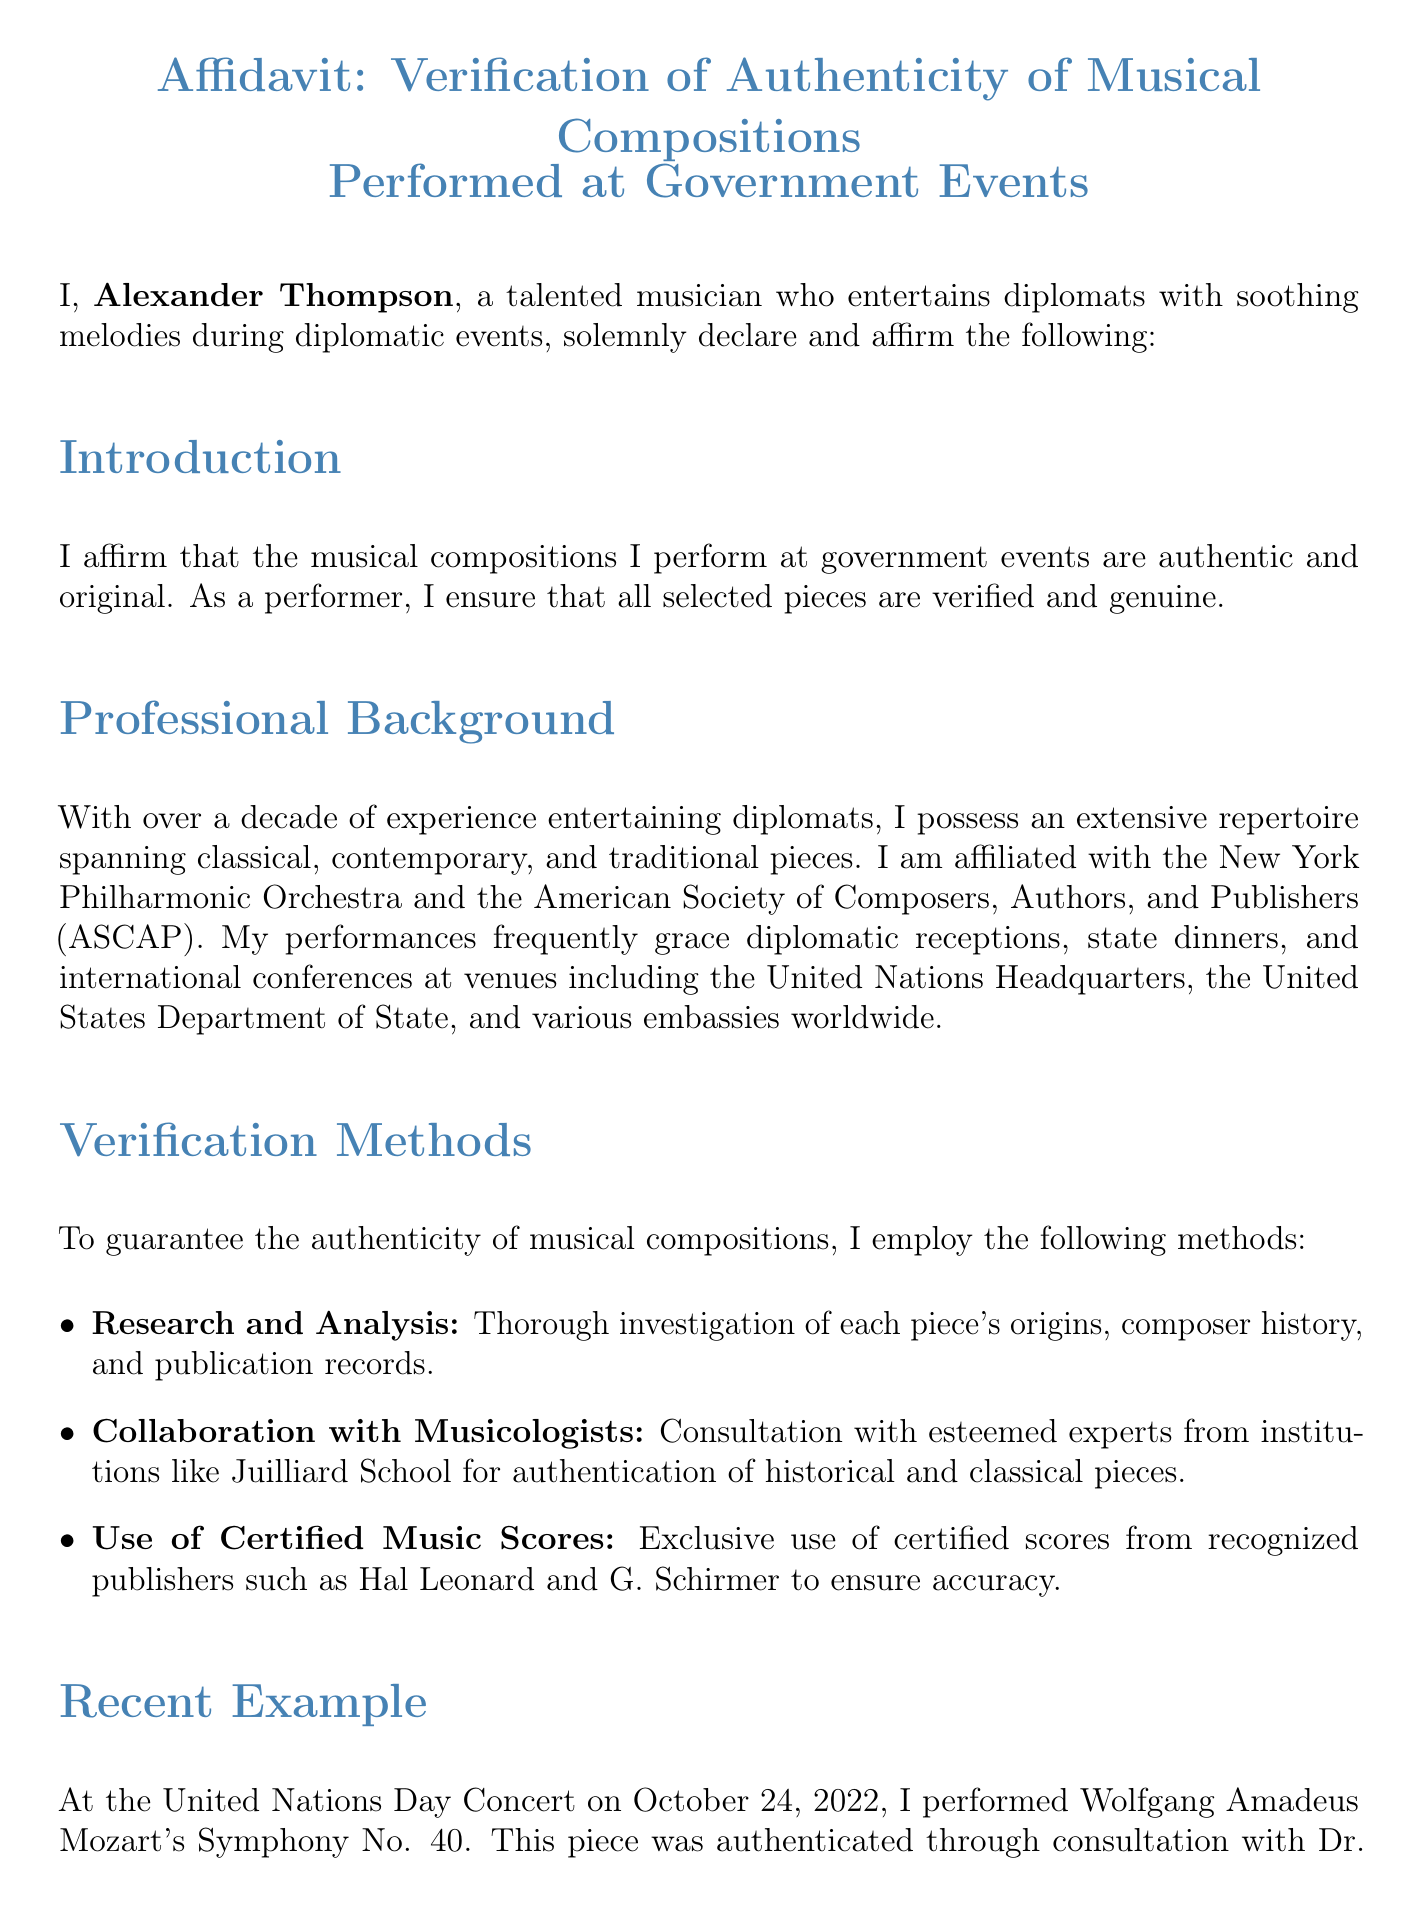What is the name of the musician? The musician's name is stated at the beginning of the document, identifying them as Alexander Thompson.
Answer: Alexander Thompson What event did Alexander Thompson perform at on October 24, 2022? The document specifies that he performed at the United Nations Day Concert on that date.
Answer: United Nations Day Concert Which symphony did he perform? The affidavit mentions that he performed Mozart's Symphony No. 40.
Answer: Symphony No. 40 What organization is Alexander Thompson affiliated with? The document lists his affiliation with the American Society of Composers, Authors, and Publishers.
Answer: American Society of Composers, Authors, and Publishers Who did Alexander consult for authentication of the piece? The affidavit refers to Dr. Mark Evans as the musicologist he consulted.
Answer: Dr. Mark Evans What is one method used for verifying musical compositions? The document mentions several methods, one of which is thorough investigation of each piece's origins.
Answer: Research and Analysis How many years of experience does Alexander Thompson have? The affidavit states that he has over a decade of experience.
Answer: Over a decade What does Alexander affirm under penalty of? The document concludes with his affirmation under penalty of perjury.
Answer: Perjury What is the date of the affidavit? The document provides the date as October 15, 2023.
Answer: October 15, 2023 